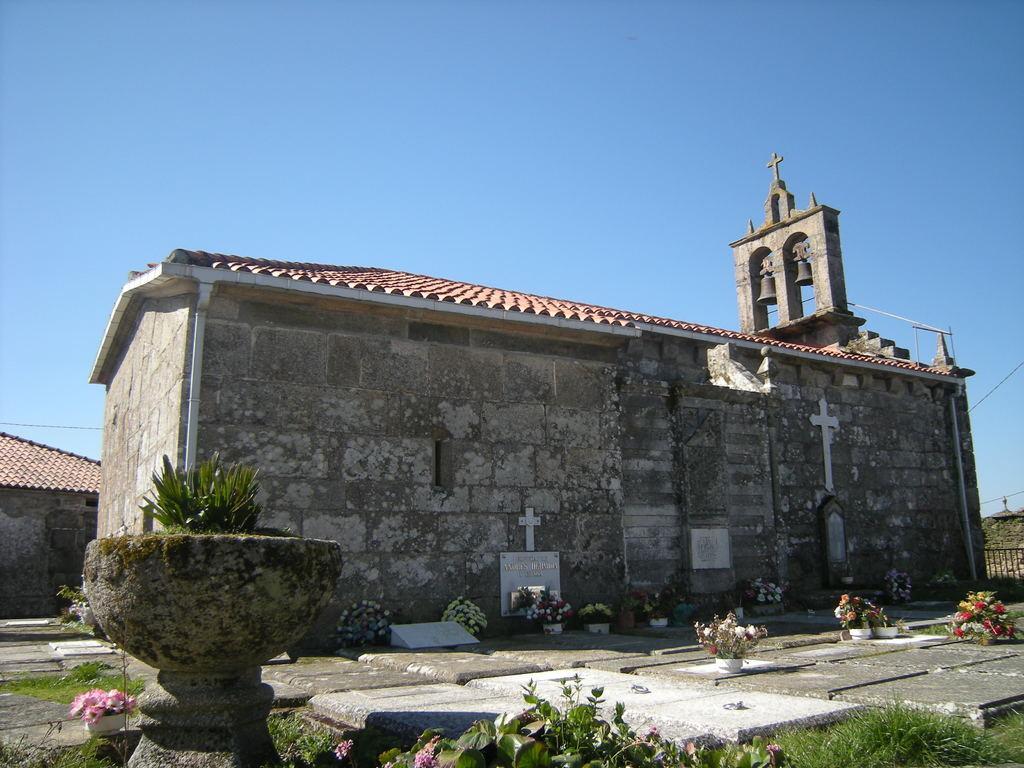Could you give a brief overview of what you see in this image? In this image I can see two buildings with a bell tower on one building at the top. I can see some potted plants and other plants at the bottom of the image. At the top of the image I can see the sky. 